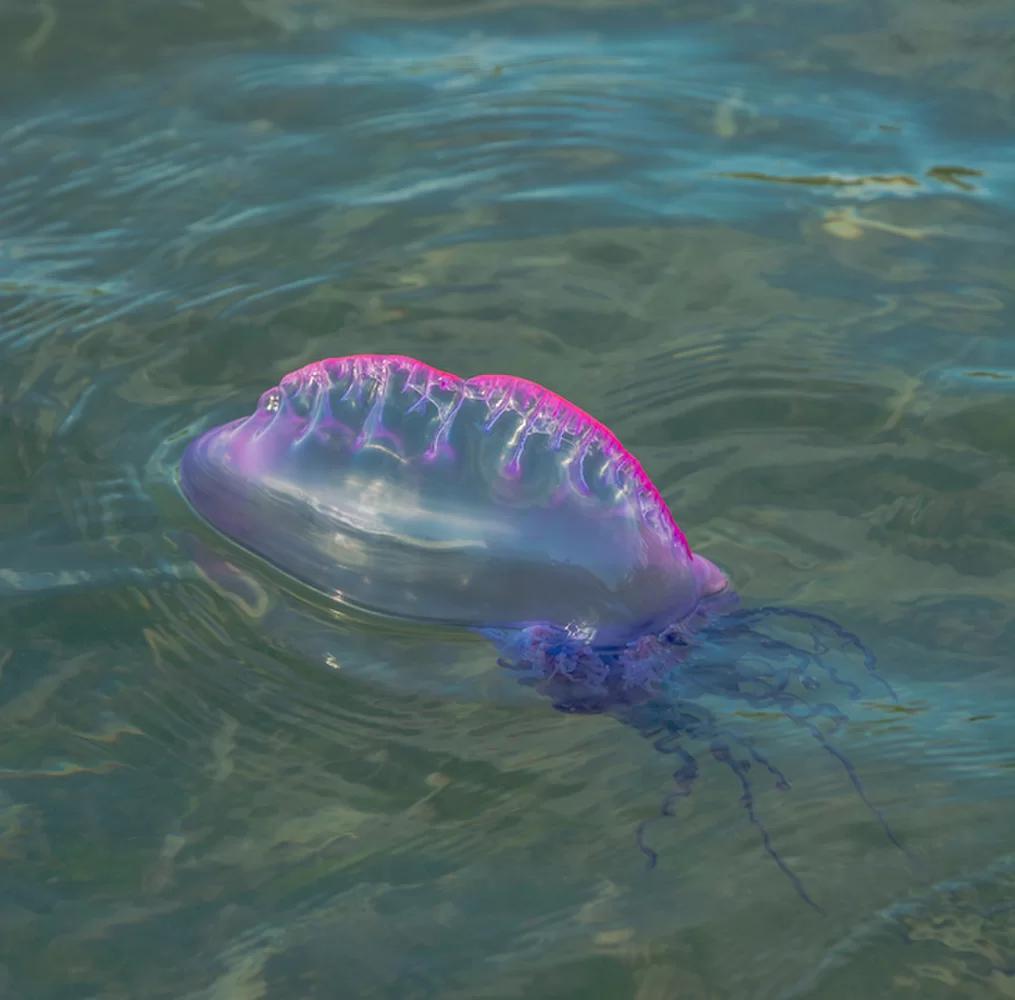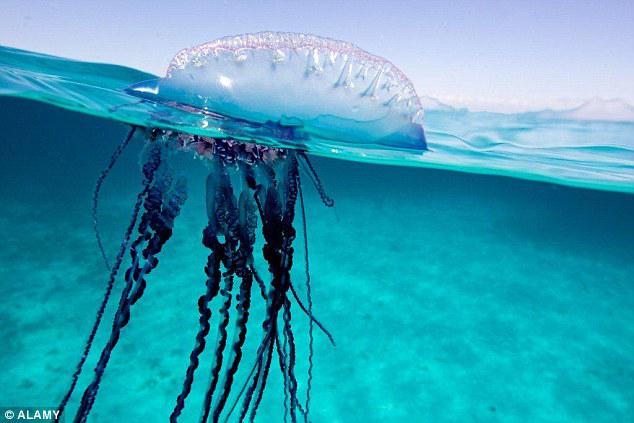The first image is the image on the left, the second image is the image on the right. Considering the images on both sides, is "In one image, a single jelly fish skims the top of the water with the sky in the background." valid? Answer yes or no. Yes. The first image is the image on the left, the second image is the image on the right. Given the left and right images, does the statement "All jellyfish are at least partially above the water surface." hold true? Answer yes or no. Yes. 